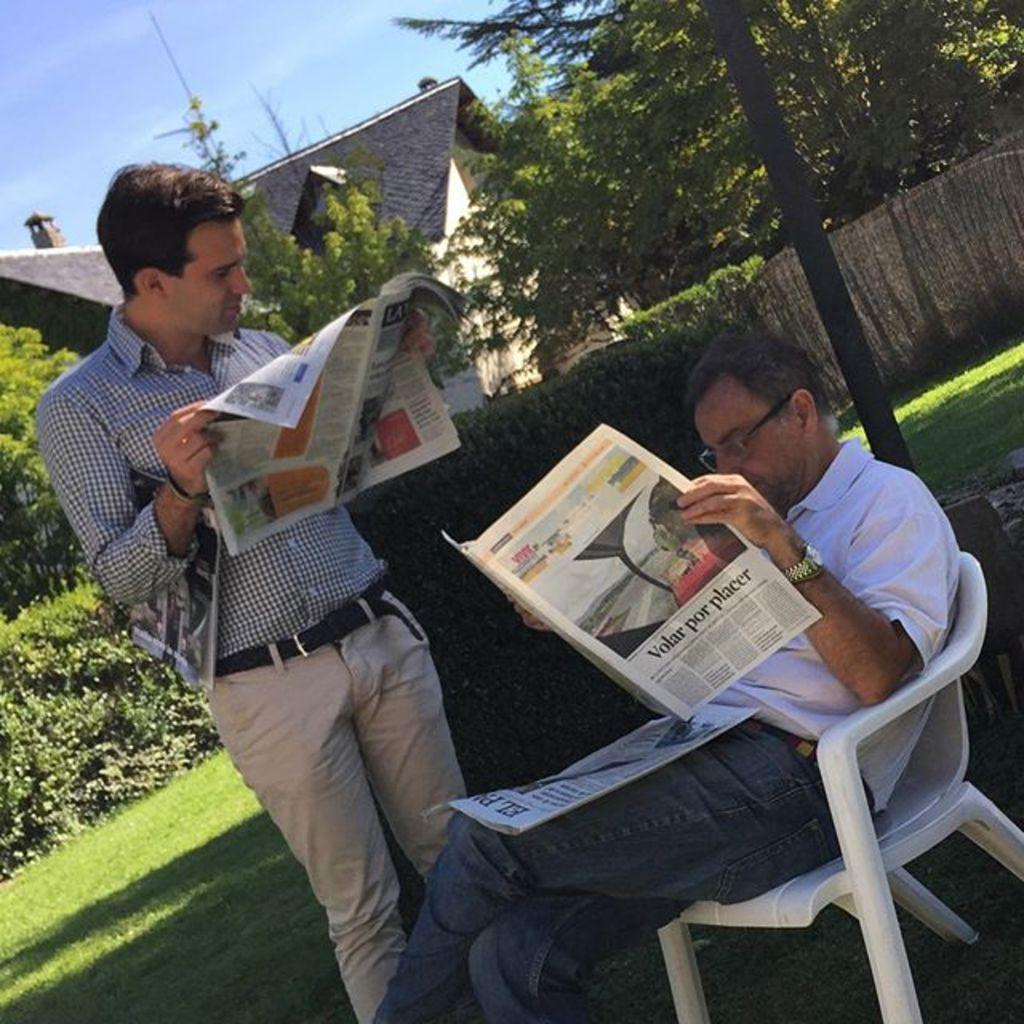What is the man in the chair doing in the image? The man in the chair is standing and reading a newspaper. Who is with the man in the chair? There is another man standing beside him, and he is also reading a newspaper. What can be seen in the background of the image? There are trees and a house in the background of the image. What type of flesh can be seen on the doll in the image? There is no doll present in the image, and therefore no flesh can be observed. What is the grandmother doing in the image? There is no mention of a grandmother in the provided facts, so it cannot be determined what she might be doing in the image. 